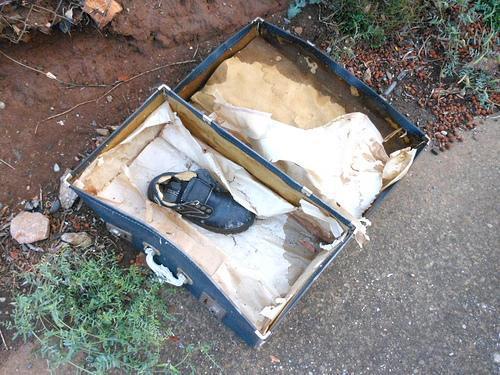How many shoes are pictured?
Give a very brief answer. 1. How many boxes are there?
Give a very brief answer. 1. 